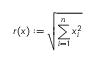Convert formula to latex. <formula><loc_0><loc_0><loc_500><loc_500>r ( x ) \colon = \sqrt { \sum _ { i = 1 } ^ { n } x _ { i } ^ { 2 } }</formula> 